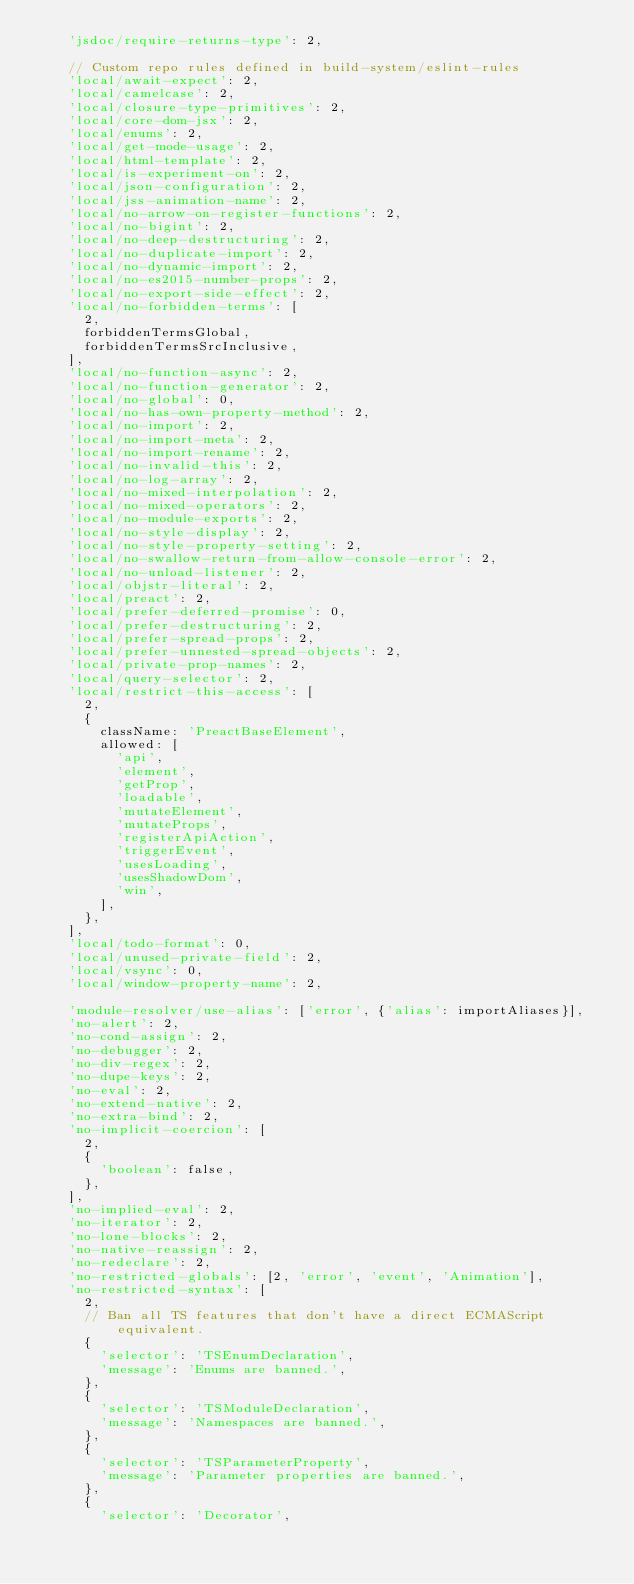<code> <loc_0><loc_0><loc_500><loc_500><_JavaScript_>    'jsdoc/require-returns-type': 2,

    // Custom repo rules defined in build-system/eslint-rules
    'local/await-expect': 2,
    'local/camelcase': 2,
    'local/closure-type-primitives': 2,
    'local/core-dom-jsx': 2,
    'local/enums': 2,
    'local/get-mode-usage': 2,
    'local/html-template': 2,
    'local/is-experiment-on': 2,
    'local/json-configuration': 2,
    'local/jss-animation-name': 2,
    'local/no-arrow-on-register-functions': 2,
    'local/no-bigint': 2,
    'local/no-deep-destructuring': 2,
    'local/no-duplicate-import': 2,
    'local/no-dynamic-import': 2,
    'local/no-es2015-number-props': 2,
    'local/no-export-side-effect': 2,
    'local/no-forbidden-terms': [
      2,
      forbiddenTermsGlobal,
      forbiddenTermsSrcInclusive,
    ],
    'local/no-function-async': 2,
    'local/no-function-generator': 2,
    'local/no-global': 0,
    'local/no-has-own-property-method': 2,
    'local/no-import': 2,
    'local/no-import-meta': 2,
    'local/no-import-rename': 2,
    'local/no-invalid-this': 2,
    'local/no-log-array': 2,
    'local/no-mixed-interpolation': 2,
    'local/no-mixed-operators': 2,
    'local/no-module-exports': 2,
    'local/no-style-display': 2,
    'local/no-style-property-setting': 2,
    'local/no-swallow-return-from-allow-console-error': 2,
    'local/no-unload-listener': 2,
    'local/objstr-literal': 2,
    'local/preact': 2,
    'local/prefer-deferred-promise': 0,
    'local/prefer-destructuring': 2,
    'local/prefer-spread-props': 2,
    'local/prefer-unnested-spread-objects': 2,
    'local/private-prop-names': 2,
    'local/query-selector': 2,
    'local/restrict-this-access': [
      2,
      {
        className: 'PreactBaseElement',
        allowed: [
          'api',
          'element',
          'getProp',
          'loadable',
          'mutateElement',
          'mutateProps',
          'registerApiAction',
          'triggerEvent',
          'usesLoading',
          'usesShadowDom',
          'win',
        ],
      },
    ],
    'local/todo-format': 0,
    'local/unused-private-field': 2,
    'local/vsync': 0,
    'local/window-property-name': 2,

    'module-resolver/use-alias': ['error', {'alias': importAliases}],
    'no-alert': 2,
    'no-cond-assign': 2,
    'no-debugger': 2,
    'no-div-regex': 2,
    'no-dupe-keys': 2,
    'no-eval': 2,
    'no-extend-native': 2,
    'no-extra-bind': 2,
    'no-implicit-coercion': [
      2,
      {
        'boolean': false,
      },
    ],
    'no-implied-eval': 2,
    'no-iterator': 2,
    'no-lone-blocks': 2,
    'no-native-reassign': 2,
    'no-redeclare': 2,
    'no-restricted-globals': [2, 'error', 'event', 'Animation'],
    'no-restricted-syntax': [
      2,
      // Ban all TS features that don't have a direct ECMAScript equivalent.
      {
        'selector': 'TSEnumDeclaration',
        'message': 'Enums are banned.',
      },
      {
        'selector': 'TSModuleDeclaration',
        'message': 'Namespaces are banned.',
      },
      {
        'selector': 'TSParameterProperty',
        'message': 'Parameter properties are banned.',
      },
      {
        'selector': 'Decorator',</code> 